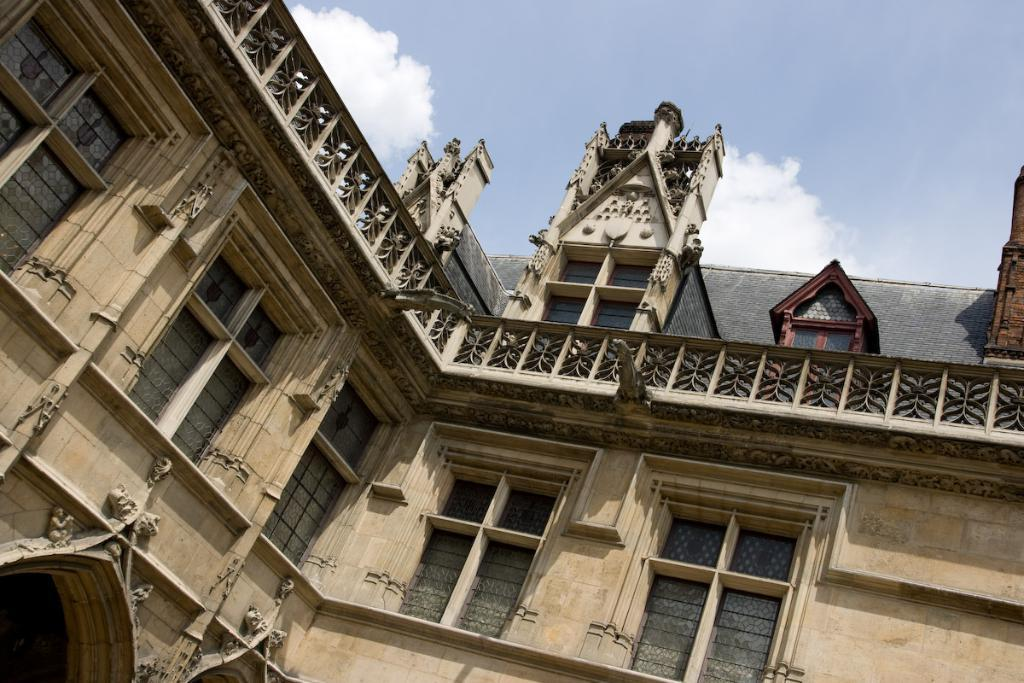What type of structure is present in the image? There is a building in the image. What features can be observed on the building? The building has windows and a railing. Are there any other objects or structures visible in the image? Yes, there are other objects in the image. What can be seen in the top right corner of the image? The sky is visible at the top right side of the image. What is the price of the knee brace in the image? There is no knee brace present in the image, so it is not possible to determine its price. 